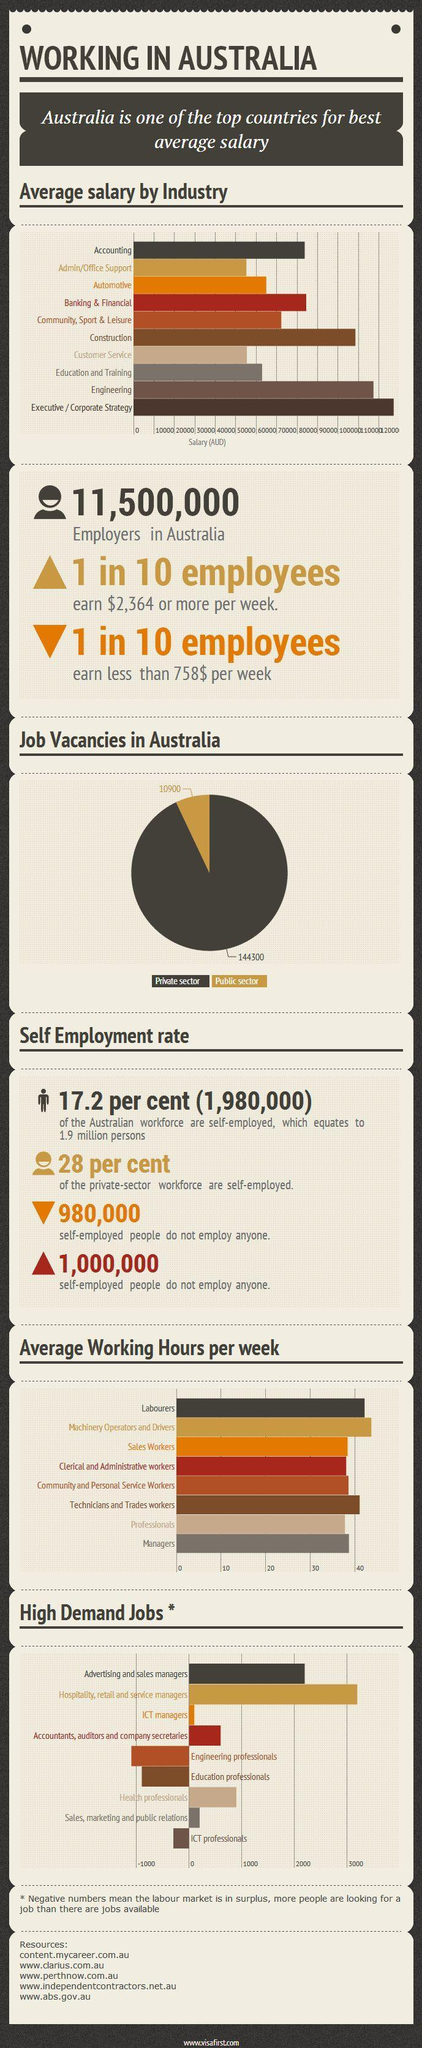Which is the third highest paying industry in Australia?
Answer the question with a short phrase. Construction Which job in Australia demands the longest average working hours per week? Machinery Operators and Drivers What is the number of job vacancies available in the public sector in Australia? 144300 Which is the highest paying industry in Australia? Executive / Corporate Strategy Which job in Australia demands the second longest average working hours per week? Labourers Which is the most demanded job in Australia? Hospitality, retail and service managers Which is the second highest paying industry in Australia? Engineering What is the number of job vacancies available in the private sector in Australia? 10900 Which is the least paying industry other then the admin/office support in Australia? Customer Service 